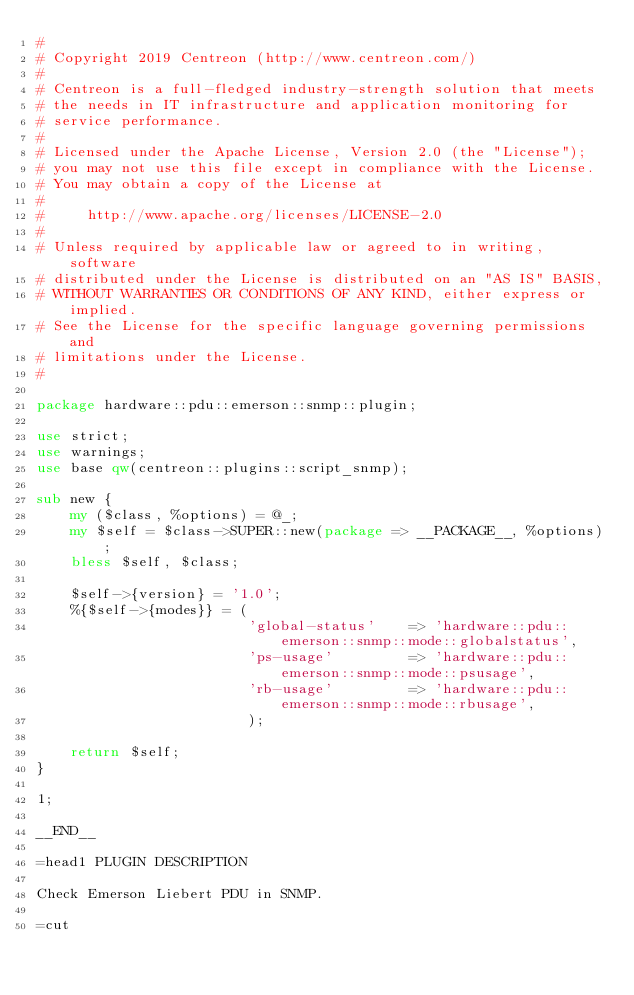Convert code to text. <code><loc_0><loc_0><loc_500><loc_500><_Perl_>#
# Copyright 2019 Centreon (http://www.centreon.com/)
#
# Centreon is a full-fledged industry-strength solution that meets
# the needs in IT infrastructure and application monitoring for
# service performance.
#
# Licensed under the Apache License, Version 2.0 (the "License");
# you may not use this file except in compliance with the License.
# You may obtain a copy of the License at
#
#     http://www.apache.org/licenses/LICENSE-2.0
#
# Unless required by applicable law or agreed to in writing, software
# distributed under the License is distributed on an "AS IS" BASIS,
# WITHOUT WARRANTIES OR CONDITIONS OF ANY KIND, either express or implied.
# See the License for the specific language governing permissions and
# limitations under the License.
#

package hardware::pdu::emerson::snmp::plugin;

use strict;
use warnings;
use base qw(centreon::plugins::script_snmp);

sub new {
    my ($class, %options) = @_;
    my $self = $class->SUPER::new(package => __PACKAGE__, %options);
    bless $self, $class;

    $self->{version} = '1.0';
    %{$self->{modes}} = (
                         'global-status'    => 'hardware::pdu::emerson::snmp::mode::globalstatus',
                         'ps-usage'         => 'hardware::pdu::emerson::snmp::mode::psusage',
                         'rb-usage'         => 'hardware::pdu::emerson::snmp::mode::rbusage',
                         );

    return $self;
}

1;

__END__

=head1 PLUGIN DESCRIPTION

Check Emerson Liebert PDU in SNMP.

=cut
</code> 